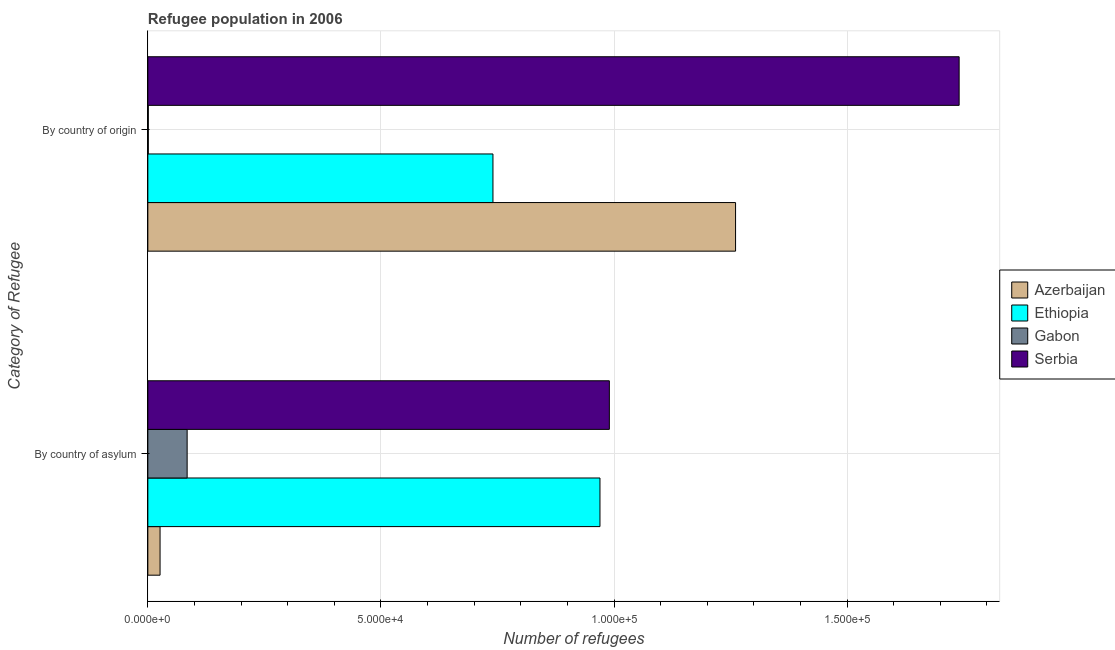How many groups of bars are there?
Provide a succinct answer. 2. Are the number of bars on each tick of the Y-axis equal?
Provide a short and direct response. Yes. How many bars are there on the 1st tick from the top?
Your answer should be very brief. 4. What is the label of the 1st group of bars from the top?
Provide a succinct answer. By country of origin. What is the number of refugees by country of origin in Serbia?
Your response must be concise. 1.74e+05. Across all countries, what is the maximum number of refugees by country of origin?
Provide a succinct answer. 1.74e+05. Across all countries, what is the minimum number of refugees by country of asylum?
Keep it short and to the point. 2618. In which country was the number of refugees by country of asylum maximum?
Your answer should be very brief. Serbia. In which country was the number of refugees by country of origin minimum?
Your answer should be compact. Gabon. What is the total number of refugees by country of asylum in the graph?
Your answer should be compact. 2.07e+05. What is the difference between the number of refugees by country of origin in Gabon and that in Serbia?
Offer a very short reply. -1.74e+05. What is the difference between the number of refugees by country of origin in Ethiopia and the number of refugees by country of asylum in Azerbaijan?
Your answer should be compact. 7.14e+04. What is the average number of refugees by country of origin per country?
Offer a terse response. 9.36e+04. What is the difference between the number of refugees by country of origin and number of refugees by country of asylum in Serbia?
Your response must be concise. 7.50e+04. What is the ratio of the number of refugees by country of asylum in Gabon to that in Ethiopia?
Your response must be concise. 0.09. Is the number of refugees by country of origin in Gabon less than that in Azerbaijan?
Ensure brevity in your answer.  Yes. What does the 3rd bar from the top in By country of asylum represents?
Your answer should be compact. Ethiopia. What does the 1st bar from the bottom in By country of origin represents?
Provide a succinct answer. Azerbaijan. Are all the bars in the graph horizontal?
Your response must be concise. Yes. Does the graph contain grids?
Offer a very short reply. Yes. How many legend labels are there?
Provide a short and direct response. 4. How are the legend labels stacked?
Ensure brevity in your answer.  Vertical. What is the title of the graph?
Your response must be concise. Refugee population in 2006. What is the label or title of the X-axis?
Provide a short and direct response. Number of refugees. What is the label or title of the Y-axis?
Make the answer very short. Category of Refugee. What is the Number of refugees in Azerbaijan in By country of asylum?
Give a very brief answer. 2618. What is the Number of refugees in Ethiopia in By country of asylum?
Ensure brevity in your answer.  9.70e+04. What is the Number of refugees in Gabon in By country of asylum?
Offer a terse response. 8429. What is the Number of refugees of Serbia in By country of asylum?
Provide a short and direct response. 9.90e+04. What is the Number of refugees of Azerbaijan in By country of origin?
Keep it short and to the point. 1.26e+05. What is the Number of refugees of Ethiopia in By country of origin?
Offer a terse response. 7.40e+04. What is the Number of refugees of Gabon in By country of origin?
Ensure brevity in your answer.  95. What is the Number of refugees in Serbia in By country of origin?
Your response must be concise. 1.74e+05. Across all Category of Refugee, what is the maximum Number of refugees of Azerbaijan?
Ensure brevity in your answer.  1.26e+05. Across all Category of Refugee, what is the maximum Number of refugees in Ethiopia?
Offer a very short reply. 9.70e+04. Across all Category of Refugee, what is the maximum Number of refugees of Gabon?
Your answer should be compact. 8429. Across all Category of Refugee, what is the maximum Number of refugees in Serbia?
Make the answer very short. 1.74e+05. Across all Category of Refugee, what is the minimum Number of refugees of Azerbaijan?
Make the answer very short. 2618. Across all Category of Refugee, what is the minimum Number of refugees of Ethiopia?
Ensure brevity in your answer.  7.40e+04. Across all Category of Refugee, what is the minimum Number of refugees in Serbia?
Ensure brevity in your answer.  9.90e+04. What is the total Number of refugees in Azerbaijan in the graph?
Offer a terse response. 1.29e+05. What is the total Number of refugees in Ethiopia in the graph?
Provide a short and direct response. 1.71e+05. What is the total Number of refugees of Gabon in the graph?
Provide a succinct answer. 8524. What is the total Number of refugees of Serbia in the graph?
Provide a short and direct response. 2.73e+05. What is the difference between the Number of refugees of Azerbaijan in By country of asylum and that in By country of origin?
Offer a very short reply. -1.23e+05. What is the difference between the Number of refugees in Ethiopia in By country of asylum and that in By country of origin?
Offer a very short reply. 2.30e+04. What is the difference between the Number of refugees in Gabon in By country of asylum and that in By country of origin?
Give a very brief answer. 8334. What is the difference between the Number of refugees in Serbia in By country of asylum and that in By country of origin?
Give a very brief answer. -7.50e+04. What is the difference between the Number of refugees in Azerbaijan in By country of asylum and the Number of refugees in Ethiopia in By country of origin?
Make the answer very short. -7.14e+04. What is the difference between the Number of refugees of Azerbaijan in By country of asylum and the Number of refugees of Gabon in By country of origin?
Give a very brief answer. 2523. What is the difference between the Number of refugees of Azerbaijan in By country of asylum and the Number of refugees of Serbia in By country of origin?
Ensure brevity in your answer.  -1.71e+05. What is the difference between the Number of refugees of Ethiopia in By country of asylum and the Number of refugees of Gabon in By country of origin?
Provide a succinct answer. 9.69e+04. What is the difference between the Number of refugees in Ethiopia in By country of asylum and the Number of refugees in Serbia in By country of origin?
Your answer should be compact. -7.70e+04. What is the difference between the Number of refugees in Gabon in By country of asylum and the Number of refugees in Serbia in By country of origin?
Keep it short and to the point. -1.66e+05. What is the average Number of refugees of Azerbaijan per Category of Refugee?
Provide a short and direct response. 6.43e+04. What is the average Number of refugees in Ethiopia per Category of Refugee?
Ensure brevity in your answer.  8.55e+04. What is the average Number of refugees of Gabon per Category of Refugee?
Your answer should be very brief. 4262. What is the average Number of refugees of Serbia per Category of Refugee?
Make the answer very short. 1.37e+05. What is the difference between the Number of refugees in Azerbaijan and Number of refugees in Ethiopia in By country of asylum?
Ensure brevity in your answer.  -9.44e+04. What is the difference between the Number of refugees in Azerbaijan and Number of refugees in Gabon in By country of asylum?
Offer a terse response. -5811. What is the difference between the Number of refugees in Azerbaijan and Number of refugees in Serbia in By country of asylum?
Provide a succinct answer. -9.64e+04. What is the difference between the Number of refugees of Ethiopia and Number of refugees of Gabon in By country of asylum?
Give a very brief answer. 8.86e+04. What is the difference between the Number of refugees in Ethiopia and Number of refugees in Serbia in By country of asylum?
Give a very brief answer. -2017. What is the difference between the Number of refugees of Gabon and Number of refugees of Serbia in By country of asylum?
Offer a very short reply. -9.06e+04. What is the difference between the Number of refugees of Azerbaijan and Number of refugees of Ethiopia in By country of origin?
Offer a terse response. 5.20e+04. What is the difference between the Number of refugees in Azerbaijan and Number of refugees in Gabon in By country of origin?
Provide a short and direct response. 1.26e+05. What is the difference between the Number of refugees in Azerbaijan and Number of refugees in Serbia in By country of origin?
Your answer should be compact. -4.80e+04. What is the difference between the Number of refugees of Ethiopia and Number of refugees of Gabon in By country of origin?
Offer a terse response. 7.39e+04. What is the difference between the Number of refugees of Ethiopia and Number of refugees of Serbia in By country of origin?
Keep it short and to the point. -1.00e+05. What is the difference between the Number of refugees in Gabon and Number of refugees in Serbia in By country of origin?
Offer a terse response. -1.74e+05. What is the ratio of the Number of refugees in Azerbaijan in By country of asylum to that in By country of origin?
Make the answer very short. 0.02. What is the ratio of the Number of refugees of Ethiopia in By country of asylum to that in By country of origin?
Your answer should be compact. 1.31. What is the ratio of the Number of refugees of Gabon in By country of asylum to that in By country of origin?
Keep it short and to the point. 88.73. What is the ratio of the Number of refugees in Serbia in By country of asylum to that in By country of origin?
Provide a succinct answer. 0.57. What is the difference between the highest and the second highest Number of refugees in Azerbaijan?
Offer a terse response. 1.23e+05. What is the difference between the highest and the second highest Number of refugees in Ethiopia?
Ensure brevity in your answer.  2.30e+04. What is the difference between the highest and the second highest Number of refugees in Gabon?
Provide a short and direct response. 8334. What is the difference between the highest and the second highest Number of refugees of Serbia?
Provide a succinct answer. 7.50e+04. What is the difference between the highest and the lowest Number of refugees in Azerbaijan?
Your answer should be compact. 1.23e+05. What is the difference between the highest and the lowest Number of refugees in Ethiopia?
Ensure brevity in your answer.  2.30e+04. What is the difference between the highest and the lowest Number of refugees of Gabon?
Ensure brevity in your answer.  8334. What is the difference between the highest and the lowest Number of refugees in Serbia?
Your answer should be compact. 7.50e+04. 